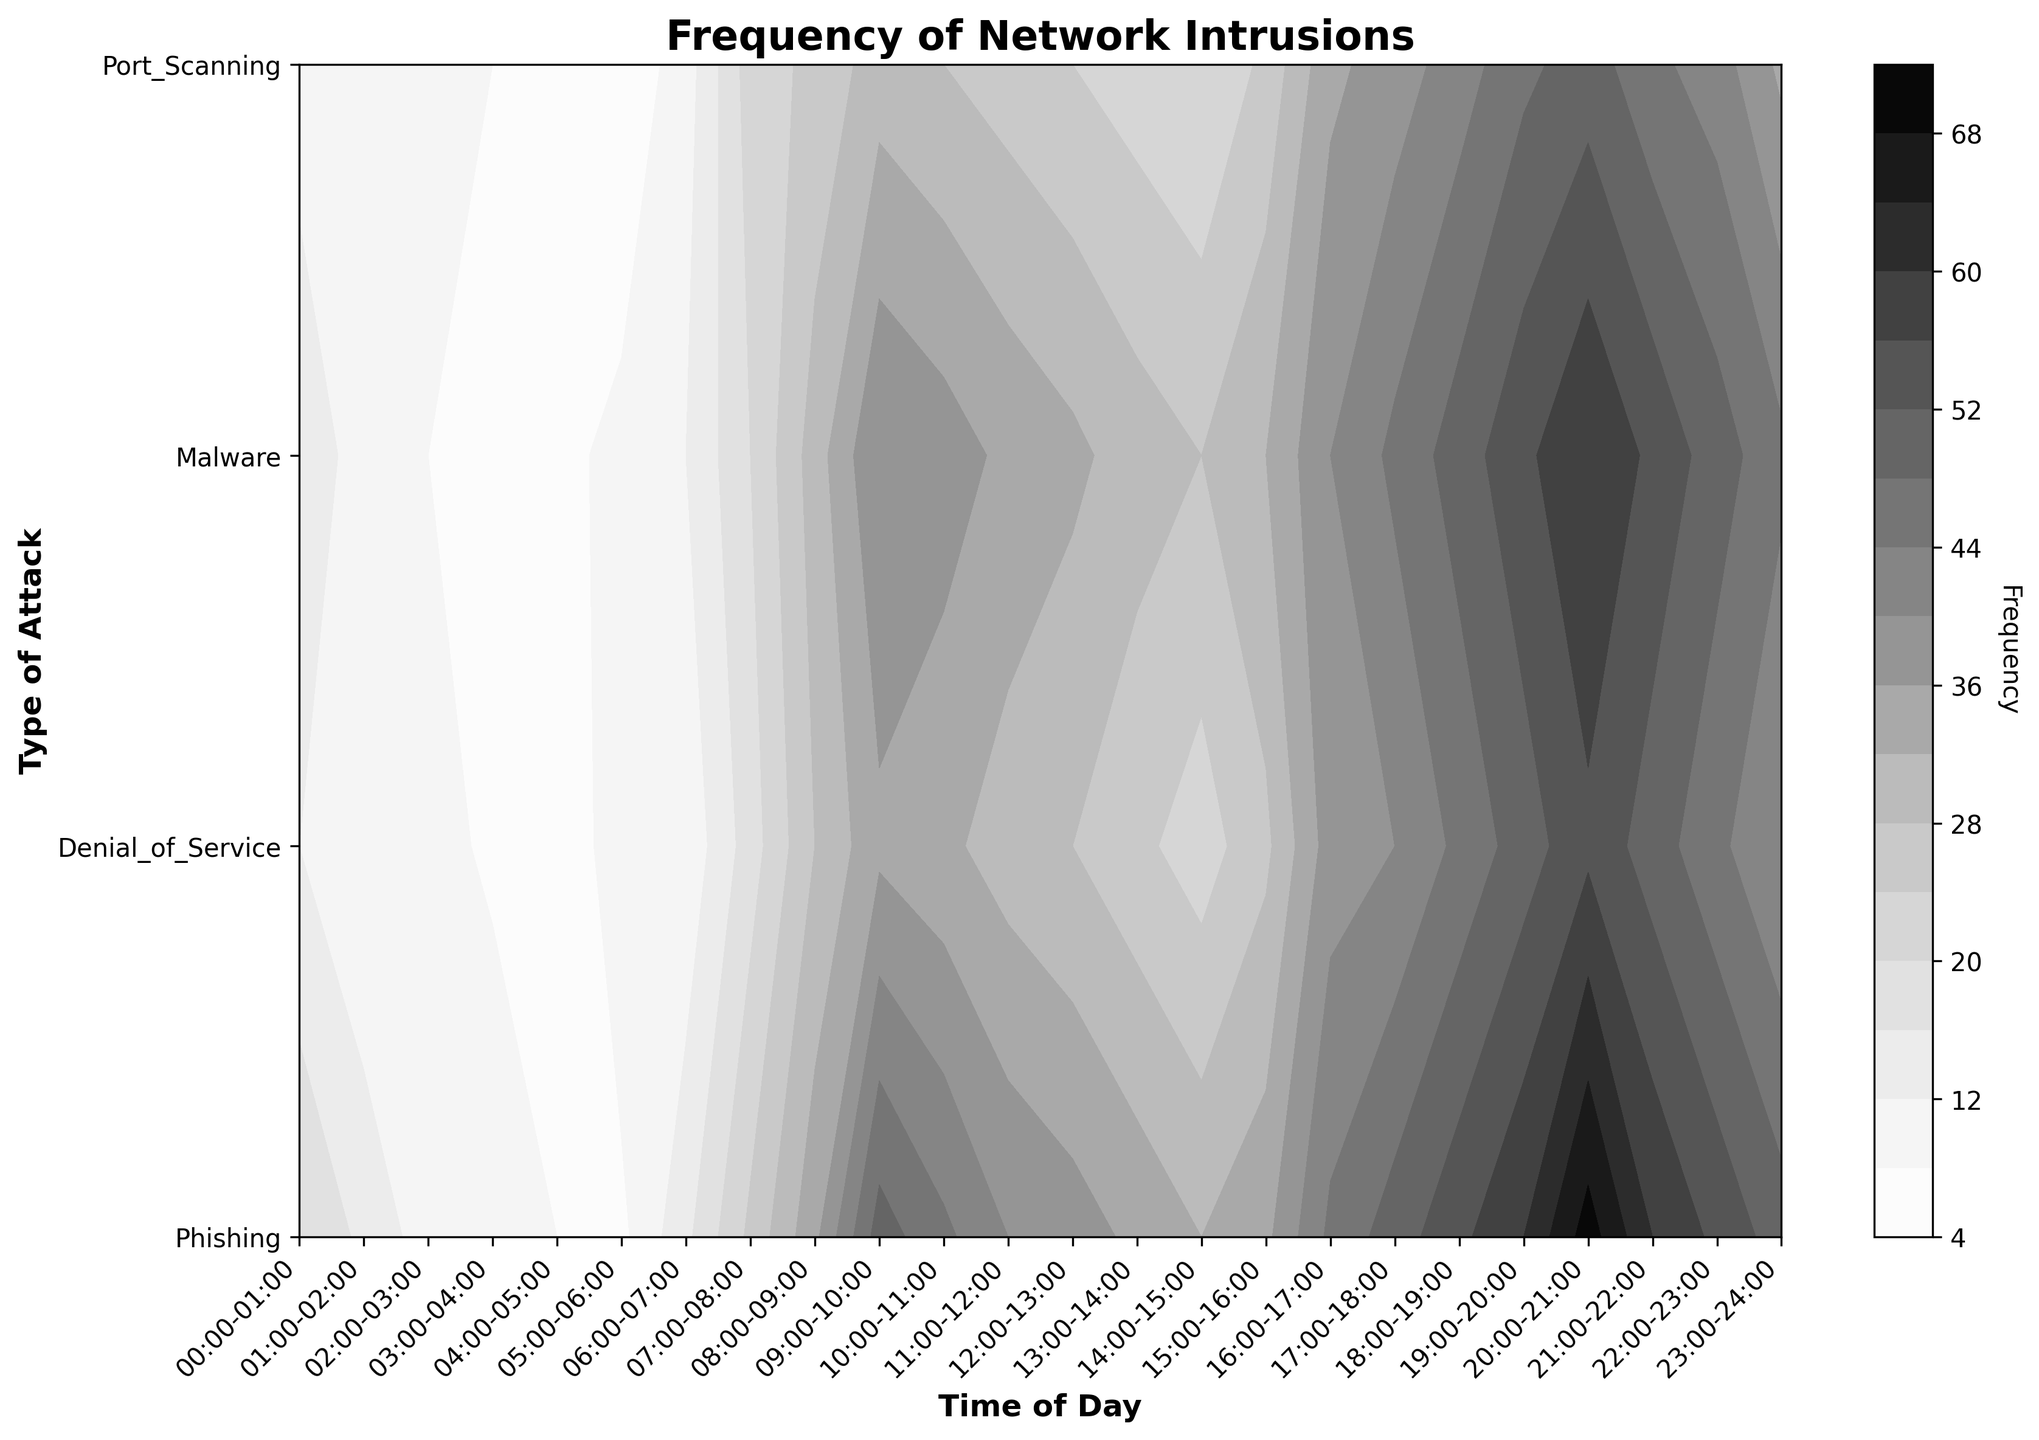what's the title of the plot? The title can be found at the top of the figure. The title is 'Frequency of Network Intrusions'.
Answer: Frequency of Network Intrusions What is the time range on the x-axis? The x-axis represents 'Time of Day'. It ranges from '00:00-01:00' to '23:00-24:00', which indicates 24 hours in a day divided into 1-hour intervals.
Answer: 00:00-01:00 to 23:00-24:00 Which type of attack has the highest frequency in the plot? By comparing the colors in the contour plot, the darkest or highest value area would indicate the maximum frequency. The 'Denial_of_Service' attack has the highest peak dark area.
Answer: Denial_of_Service At what time of the day does Phishing have its highest frequency? Look for the darkest region within the Phishing row, and then match it with the corresponding time on the x-axis. The highest frequency for Phishing occurs around '20:00-21:00'.
Answer: 20:00-21:00 How does the frequency of Port Scanning from 08:00-09:00 compare to 10:00-11:00? Find the corresponding points on the contour plot: 'Port Scanning' at '08:00-09:00' is darker and higher in value compared to '10:00-11:00'.
Answer: Higher Is there a time of day where all types of attacks have relatively low frequencies? By analyzing the lighter regions across all rows simultaneously, '04:00-05:00' shows the lowest frequency across all types of attacks.
Answer: 04:00-05:00 What periods have the highest combined frequency for all attacks? Look for the darkest areas that cover all rows together, indicating highest combined frequency. This occurs around '18:00-21:00'.
Answer: 18:00-21:00 Compare the frequency of Malware between '06:00-07:00' and '19:00-20:00'. Which one is higher? Compare the darkness levels in the color that represents Malware between these two time slots. The frequency of Malware is higher for '19:00-20:00'.
Answer: 19:00-20:00 What is the trend in the frequency of Denial of Service attacks from '08:00-09:00' to '18:00-19:00'? By examining the contour levels for Denial of Service across the specified time range, one can observe an increasing trend in frequency.
Answer: Increasing Which type of attack has the most variation in frequency throughout the day? By analyzing the contour levels for each attack, 'Denial_of_Service' exhibits the most variation as it moves from light to dark colors indicating different frequency levels.
Answer: Denial_of_Service 